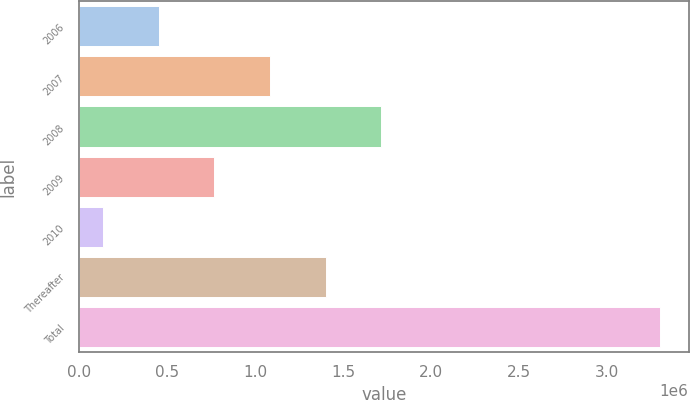Convert chart. <chart><loc_0><loc_0><loc_500><loc_500><bar_chart><fcel>2006<fcel>2007<fcel>2008<fcel>2009<fcel>2010<fcel>Thereafter<fcel>Total<nl><fcel>451019<fcel>1.0835e+06<fcel>1.71598e+06<fcel>767261<fcel>134778<fcel>1.39974e+06<fcel>3.29719e+06<nl></chart> 